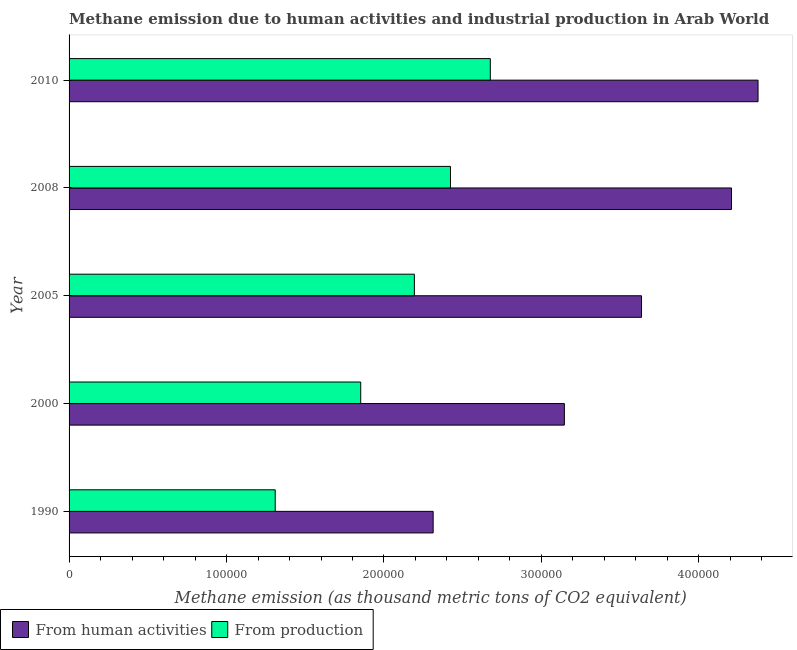Are the number of bars per tick equal to the number of legend labels?
Make the answer very short. Yes. Are the number of bars on each tick of the Y-axis equal?
Your answer should be compact. Yes. How many bars are there on the 5th tick from the top?
Provide a succinct answer. 2. In how many cases, is the number of bars for a given year not equal to the number of legend labels?
Offer a terse response. 0. What is the amount of emissions from human activities in 2008?
Give a very brief answer. 4.21e+05. Across all years, what is the maximum amount of emissions from human activities?
Provide a short and direct response. 4.38e+05. Across all years, what is the minimum amount of emissions generated from industries?
Ensure brevity in your answer.  1.31e+05. In which year was the amount of emissions from human activities maximum?
Provide a short and direct response. 2010. What is the total amount of emissions generated from industries in the graph?
Your answer should be compact. 1.05e+06. What is the difference between the amount of emissions from human activities in 1990 and that in 2000?
Your response must be concise. -8.33e+04. What is the difference between the amount of emissions generated from industries in 2008 and the amount of emissions from human activities in 2010?
Give a very brief answer. -1.95e+05. What is the average amount of emissions from human activities per year?
Provide a succinct answer. 3.54e+05. In the year 2005, what is the difference between the amount of emissions from human activities and amount of emissions generated from industries?
Offer a very short reply. 1.44e+05. In how many years, is the amount of emissions from human activities greater than 120000 thousand metric tons?
Keep it short and to the point. 5. What is the ratio of the amount of emissions from human activities in 2005 to that in 2010?
Your answer should be compact. 0.83. Is the amount of emissions from human activities in 1990 less than that in 2008?
Make the answer very short. Yes. Is the difference between the amount of emissions from human activities in 1990 and 2000 greater than the difference between the amount of emissions generated from industries in 1990 and 2000?
Give a very brief answer. No. What is the difference between the highest and the second highest amount of emissions from human activities?
Provide a succinct answer. 1.69e+04. What is the difference between the highest and the lowest amount of emissions from human activities?
Offer a very short reply. 2.06e+05. Is the sum of the amount of emissions generated from industries in 1990 and 2005 greater than the maximum amount of emissions from human activities across all years?
Offer a terse response. No. What does the 2nd bar from the top in 2000 represents?
Offer a terse response. From human activities. What does the 2nd bar from the bottom in 1990 represents?
Your answer should be very brief. From production. How many bars are there?
Give a very brief answer. 10. How many years are there in the graph?
Your response must be concise. 5. What is the difference between two consecutive major ticks on the X-axis?
Offer a terse response. 1.00e+05. Are the values on the major ticks of X-axis written in scientific E-notation?
Ensure brevity in your answer.  No. Does the graph contain any zero values?
Your answer should be very brief. No. Does the graph contain grids?
Make the answer very short. No. Where does the legend appear in the graph?
Your answer should be very brief. Bottom left. How many legend labels are there?
Your answer should be very brief. 2. How are the legend labels stacked?
Provide a short and direct response. Horizontal. What is the title of the graph?
Offer a terse response. Methane emission due to human activities and industrial production in Arab World. What is the label or title of the X-axis?
Your answer should be very brief. Methane emission (as thousand metric tons of CO2 equivalent). What is the Methane emission (as thousand metric tons of CO2 equivalent) in From human activities in 1990?
Make the answer very short. 2.31e+05. What is the Methane emission (as thousand metric tons of CO2 equivalent) in From production in 1990?
Make the answer very short. 1.31e+05. What is the Methane emission (as thousand metric tons of CO2 equivalent) of From human activities in 2000?
Ensure brevity in your answer.  3.15e+05. What is the Methane emission (as thousand metric tons of CO2 equivalent) in From production in 2000?
Keep it short and to the point. 1.85e+05. What is the Methane emission (as thousand metric tons of CO2 equivalent) of From human activities in 2005?
Ensure brevity in your answer.  3.64e+05. What is the Methane emission (as thousand metric tons of CO2 equivalent) in From production in 2005?
Your response must be concise. 2.19e+05. What is the Methane emission (as thousand metric tons of CO2 equivalent) in From human activities in 2008?
Offer a terse response. 4.21e+05. What is the Methane emission (as thousand metric tons of CO2 equivalent) in From production in 2008?
Offer a very short reply. 2.42e+05. What is the Methane emission (as thousand metric tons of CO2 equivalent) in From human activities in 2010?
Ensure brevity in your answer.  4.38e+05. What is the Methane emission (as thousand metric tons of CO2 equivalent) in From production in 2010?
Keep it short and to the point. 2.68e+05. Across all years, what is the maximum Methane emission (as thousand metric tons of CO2 equivalent) in From human activities?
Give a very brief answer. 4.38e+05. Across all years, what is the maximum Methane emission (as thousand metric tons of CO2 equivalent) of From production?
Give a very brief answer. 2.68e+05. Across all years, what is the minimum Methane emission (as thousand metric tons of CO2 equivalent) of From human activities?
Your answer should be compact. 2.31e+05. Across all years, what is the minimum Methane emission (as thousand metric tons of CO2 equivalent) in From production?
Make the answer very short. 1.31e+05. What is the total Methane emission (as thousand metric tons of CO2 equivalent) of From human activities in the graph?
Provide a succinct answer. 1.77e+06. What is the total Methane emission (as thousand metric tons of CO2 equivalent) of From production in the graph?
Keep it short and to the point. 1.05e+06. What is the difference between the Methane emission (as thousand metric tons of CO2 equivalent) of From human activities in 1990 and that in 2000?
Ensure brevity in your answer.  -8.33e+04. What is the difference between the Methane emission (as thousand metric tons of CO2 equivalent) in From production in 1990 and that in 2000?
Keep it short and to the point. -5.43e+04. What is the difference between the Methane emission (as thousand metric tons of CO2 equivalent) of From human activities in 1990 and that in 2005?
Make the answer very short. -1.32e+05. What is the difference between the Methane emission (as thousand metric tons of CO2 equivalent) of From production in 1990 and that in 2005?
Keep it short and to the point. -8.84e+04. What is the difference between the Methane emission (as thousand metric tons of CO2 equivalent) of From human activities in 1990 and that in 2008?
Provide a short and direct response. -1.89e+05. What is the difference between the Methane emission (as thousand metric tons of CO2 equivalent) in From production in 1990 and that in 2008?
Your response must be concise. -1.11e+05. What is the difference between the Methane emission (as thousand metric tons of CO2 equivalent) of From human activities in 1990 and that in 2010?
Your response must be concise. -2.06e+05. What is the difference between the Methane emission (as thousand metric tons of CO2 equivalent) of From production in 1990 and that in 2010?
Your answer should be compact. -1.37e+05. What is the difference between the Methane emission (as thousand metric tons of CO2 equivalent) in From human activities in 2000 and that in 2005?
Your answer should be very brief. -4.90e+04. What is the difference between the Methane emission (as thousand metric tons of CO2 equivalent) of From production in 2000 and that in 2005?
Your response must be concise. -3.41e+04. What is the difference between the Methane emission (as thousand metric tons of CO2 equivalent) in From human activities in 2000 and that in 2008?
Your response must be concise. -1.06e+05. What is the difference between the Methane emission (as thousand metric tons of CO2 equivalent) of From production in 2000 and that in 2008?
Provide a short and direct response. -5.70e+04. What is the difference between the Methane emission (as thousand metric tons of CO2 equivalent) in From human activities in 2000 and that in 2010?
Your answer should be compact. -1.23e+05. What is the difference between the Methane emission (as thousand metric tons of CO2 equivalent) in From production in 2000 and that in 2010?
Provide a succinct answer. -8.23e+04. What is the difference between the Methane emission (as thousand metric tons of CO2 equivalent) of From human activities in 2005 and that in 2008?
Provide a short and direct response. -5.71e+04. What is the difference between the Methane emission (as thousand metric tons of CO2 equivalent) of From production in 2005 and that in 2008?
Provide a succinct answer. -2.29e+04. What is the difference between the Methane emission (as thousand metric tons of CO2 equivalent) of From human activities in 2005 and that in 2010?
Your answer should be compact. -7.40e+04. What is the difference between the Methane emission (as thousand metric tons of CO2 equivalent) in From production in 2005 and that in 2010?
Give a very brief answer. -4.82e+04. What is the difference between the Methane emission (as thousand metric tons of CO2 equivalent) of From human activities in 2008 and that in 2010?
Your response must be concise. -1.69e+04. What is the difference between the Methane emission (as thousand metric tons of CO2 equivalent) in From production in 2008 and that in 2010?
Your answer should be very brief. -2.53e+04. What is the difference between the Methane emission (as thousand metric tons of CO2 equivalent) in From human activities in 1990 and the Methane emission (as thousand metric tons of CO2 equivalent) in From production in 2000?
Make the answer very short. 4.60e+04. What is the difference between the Methane emission (as thousand metric tons of CO2 equivalent) in From human activities in 1990 and the Methane emission (as thousand metric tons of CO2 equivalent) in From production in 2005?
Offer a very short reply. 1.19e+04. What is the difference between the Methane emission (as thousand metric tons of CO2 equivalent) of From human activities in 1990 and the Methane emission (as thousand metric tons of CO2 equivalent) of From production in 2008?
Your answer should be very brief. -1.10e+04. What is the difference between the Methane emission (as thousand metric tons of CO2 equivalent) in From human activities in 1990 and the Methane emission (as thousand metric tons of CO2 equivalent) in From production in 2010?
Make the answer very short. -3.63e+04. What is the difference between the Methane emission (as thousand metric tons of CO2 equivalent) in From human activities in 2000 and the Methane emission (as thousand metric tons of CO2 equivalent) in From production in 2005?
Ensure brevity in your answer.  9.53e+04. What is the difference between the Methane emission (as thousand metric tons of CO2 equivalent) of From human activities in 2000 and the Methane emission (as thousand metric tons of CO2 equivalent) of From production in 2008?
Offer a terse response. 7.23e+04. What is the difference between the Methane emission (as thousand metric tons of CO2 equivalent) of From human activities in 2000 and the Methane emission (as thousand metric tons of CO2 equivalent) of From production in 2010?
Your response must be concise. 4.70e+04. What is the difference between the Methane emission (as thousand metric tons of CO2 equivalent) of From human activities in 2005 and the Methane emission (as thousand metric tons of CO2 equivalent) of From production in 2008?
Keep it short and to the point. 1.21e+05. What is the difference between the Methane emission (as thousand metric tons of CO2 equivalent) in From human activities in 2005 and the Methane emission (as thousand metric tons of CO2 equivalent) in From production in 2010?
Your response must be concise. 9.60e+04. What is the difference between the Methane emission (as thousand metric tons of CO2 equivalent) in From human activities in 2008 and the Methane emission (as thousand metric tons of CO2 equivalent) in From production in 2010?
Offer a terse response. 1.53e+05. What is the average Methane emission (as thousand metric tons of CO2 equivalent) of From human activities per year?
Provide a succinct answer. 3.54e+05. What is the average Methane emission (as thousand metric tons of CO2 equivalent) of From production per year?
Offer a very short reply. 2.09e+05. In the year 1990, what is the difference between the Methane emission (as thousand metric tons of CO2 equivalent) of From human activities and Methane emission (as thousand metric tons of CO2 equivalent) of From production?
Make the answer very short. 1.00e+05. In the year 2000, what is the difference between the Methane emission (as thousand metric tons of CO2 equivalent) in From human activities and Methane emission (as thousand metric tons of CO2 equivalent) in From production?
Keep it short and to the point. 1.29e+05. In the year 2005, what is the difference between the Methane emission (as thousand metric tons of CO2 equivalent) in From human activities and Methane emission (as thousand metric tons of CO2 equivalent) in From production?
Give a very brief answer. 1.44e+05. In the year 2008, what is the difference between the Methane emission (as thousand metric tons of CO2 equivalent) in From human activities and Methane emission (as thousand metric tons of CO2 equivalent) in From production?
Your answer should be compact. 1.78e+05. In the year 2010, what is the difference between the Methane emission (as thousand metric tons of CO2 equivalent) of From human activities and Methane emission (as thousand metric tons of CO2 equivalent) of From production?
Offer a very short reply. 1.70e+05. What is the ratio of the Methane emission (as thousand metric tons of CO2 equivalent) of From human activities in 1990 to that in 2000?
Keep it short and to the point. 0.74. What is the ratio of the Methane emission (as thousand metric tons of CO2 equivalent) of From production in 1990 to that in 2000?
Offer a terse response. 0.71. What is the ratio of the Methane emission (as thousand metric tons of CO2 equivalent) of From human activities in 1990 to that in 2005?
Your answer should be compact. 0.64. What is the ratio of the Methane emission (as thousand metric tons of CO2 equivalent) in From production in 1990 to that in 2005?
Provide a short and direct response. 0.6. What is the ratio of the Methane emission (as thousand metric tons of CO2 equivalent) in From human activities in 1990 to that in 2008?
Ensure brevity in your answer.  0.55. What is the ratio of the Methane emission (as thousand metric tons of CO2 equivalent) in From production in 1990 to that in 2008?
Offer a very short reply. 0.54. What is the ratio of the Methane emission (as thousand metric tons of CO2 equivalent) in From human activities in 1990 to that in 2010?
Provide a succinct answer. 0.53. What is the ratio of the Methane emission (as thousand metric tons of CO2 equivalent) of From production in 1990 to that in 2010?
Your answer should be very brief. 0.49. What is the ratio of the Methane emission (as thousand metric tons of CO2 equivalent) in From human activities in 2000 to that in 2005?
Your answer should be very brief. 0.87. What is the ratio of the Methane emission (as thousand metric tons of CO2 equivalent) of From production in 2000 to that in 2005?
Keep it short and to the point. 0.84. What is the ratio of the Methane emission (as thousand metric tons of CO2 equivalent) in From human activities in 2000 to that in 2008?
Make the answer very short. 0.75. What is the ratio of the Methane emission (as thousand metric tons of CO2 equivalent) in From production in 2000 to that in 2008?
Provide a short and direct response. 0.76. What is the ratio of the Methane emission (as thousand metric tons of CO2 equivalent) in From human activities in 2000 to that in 2010?
Your answer should be compact. 0.72. What is the ratio of the Methane emission (as thousand metric tons of CO2 equivalent) in From production in 2000 to that in 2010?
Your response must be concise. 0.69. What is the ratio of the Methane emission (as thousand metric tons of CO2 equivalent) in From human activities in 2005 to that in 2008?
Your answer should be very brief. 0.86. What is the ratio of the Methane emission (as thousand metric tons of CO2 equivalent) of From production in 2005 to that in 2008?
Ensure brevity in your answer.  0.91. What is the ratio of the Methane emission (as thousand metric tons of CO2 equivalent) of From human activities in 2005 to that in 2010?
Provide a succinct answer. 0.83. What is the ratio of the Methane emission (as thousand metric tons of CO2 equivalent) in From production in 2005 to that in 2010?
Offer a terse response. 0.82. What is the ratio of the Methane emission (as thousand metric tons of CO2 equivalent) in From human activities in 2008 to that in 2010?
Your answer should be compact. 0.96. What is the ratio of the Methane emission (as thousand metric tons of CO2 equivalent) in From production in 2008 to that in 2010?
Provide a succinct answer. 0.91. What is the difference between the highest and the second highest Methane emission (as thousand metric tons of CO2 equivalent) of From human activities?
Offer a very short reply. 1.69e+04. What is the difference between the highest and the second highest Methane emission (as thousand metric tons of CO2 equivalent) in From production?
Your response must be concise. 2.53e+04. What is the difference between the highest and the lowest Methane emission (as thousand metric tons of CO2 equivalent) in From human activities?
Offer a terse response. 2.06e+05. What is the difference between the highest and the lowest Methane emission (as thousand metric tons of CO2 equivalent) of From production?
Provide a succinct answer. 1.37e+05. 